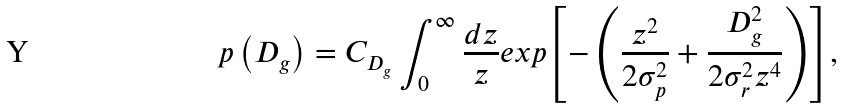<formula> <loc_0><loc_0><loc_500><loc_500>p \left ( D _ { g } \right ) = C _ { D _ { g } } \int _ { 0 } ^ { \infty } \frac { d z } { z } e x p { \left [ - \left ( \frac { z ^ { 2 } } { 2 \sigma ^ { 2 } _ { p } } + \frac { D _ { g } ^ { 2 } } { 2 \sigma _ { r } ^ { 2 } z ^ { 4 } } \right ) \right ] } ,</formula> 